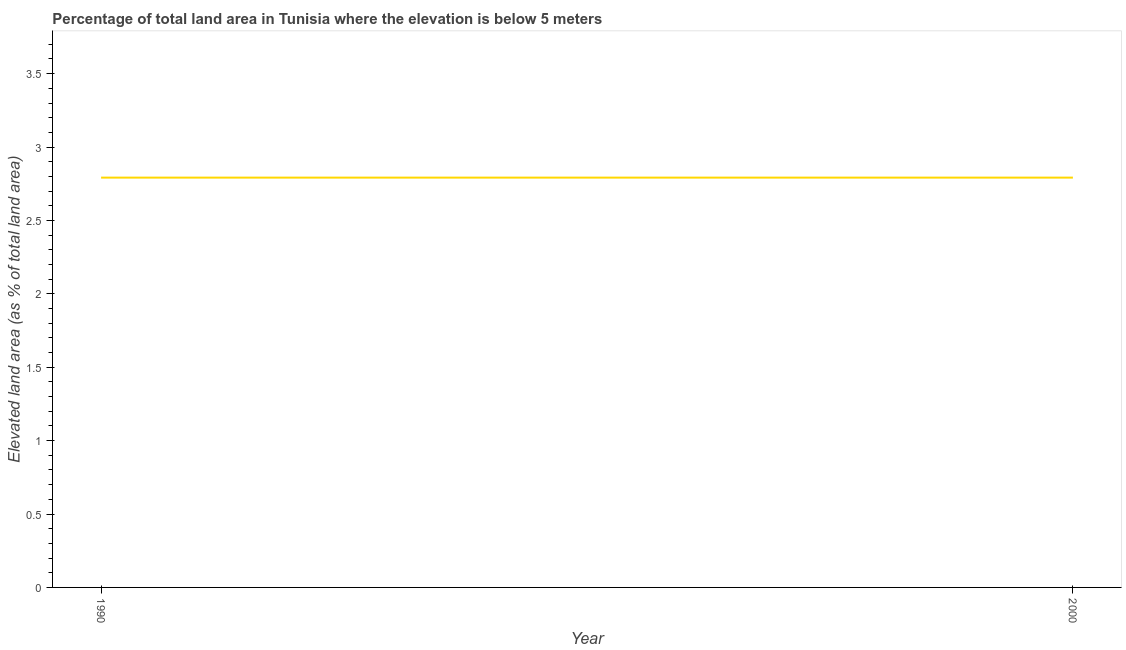What is the total elevated land area in 2000?
Your response must be concise. 2.79. Across all years, what is the maximum total elevated land area?
Offer a terse response. 2.79. Across all years, what is the minimum total elevated land area?
Provide a succinct answer. 2.79. In which year was the total elevated land area maximum?
Your answer should be compact. 1990. In which year was the total elevated land area minimum?
Your response must be concise. 1990. What is the sum of the total elevated land area?
Make the answer very short. 5.58. What is the difference between the total elevated land area in 1990 and 2000?
Make the answer very short. 0. What is the average total elevated land area per year?
Give a very brief answer. 2.79. What is the median total elevated land area?
Provide a succinct answer. 2.79. In how many years, is the total elevated land area greater than 0.2 %?
Provide a succinct answer. 2. What is the ratio of the total elevated land area in 1990 to that in 2000?
Give a very brief answer. 1. How many years are there in the graph?
Offer a terse response. 2. What is the title of the graph?
Offer a terse response. Percentage of total land area in Tunisia where the elevation is below 5 meters. What is the label or title of the Y-axis?
Keep it short and to the point. Elevated land area (as % of total land area). What is the Elevated land area (as % of total land area) in 1990?
Provide a succinct answer. 2.79. What is the Elevated land area (as % of total land area) of 2000?
Your answer should be compact. 2.79. What is the ratio of the Elevated land area (as % of total land area) in 1990 to that in 2000?
Your answer should be very brief. 1. 